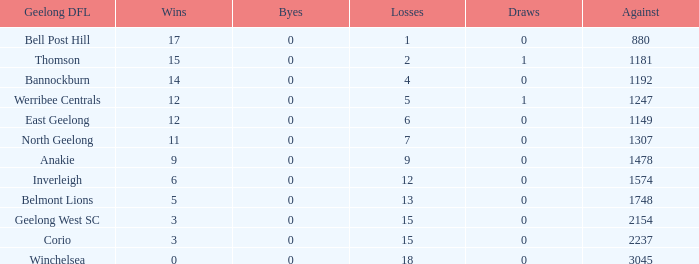How many total losses had more than 0 byes? 0.0. 